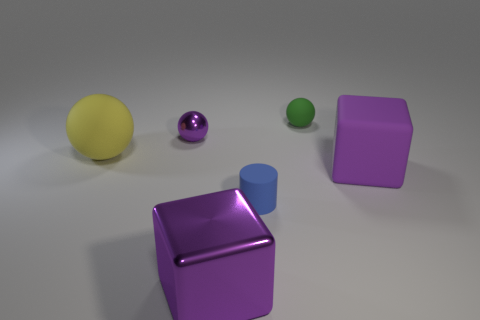Subtract all small spheres. How many spheres are left? 1 Subtract all green balls. How many balls are left? 2 Subtract all cubes. How many objects are left? 4 Add 2 purple objects. How many objects exist? 8 Subtract 1 yellow balls. How many objects are left? 5 Subtract 1 cylinders. How many cylinders are left? 0 Subtract all cyan blocks. Subtract all brown cylinders. How many blocks are left? 2 Subtract all purple spheres. How many brown cylinders are left? 0 Subtract all small green things. Subtract all rubber cylinders. How many objects are left? 4 Add 5 tiny blue objects. How many tiny blue objects are left? 6 